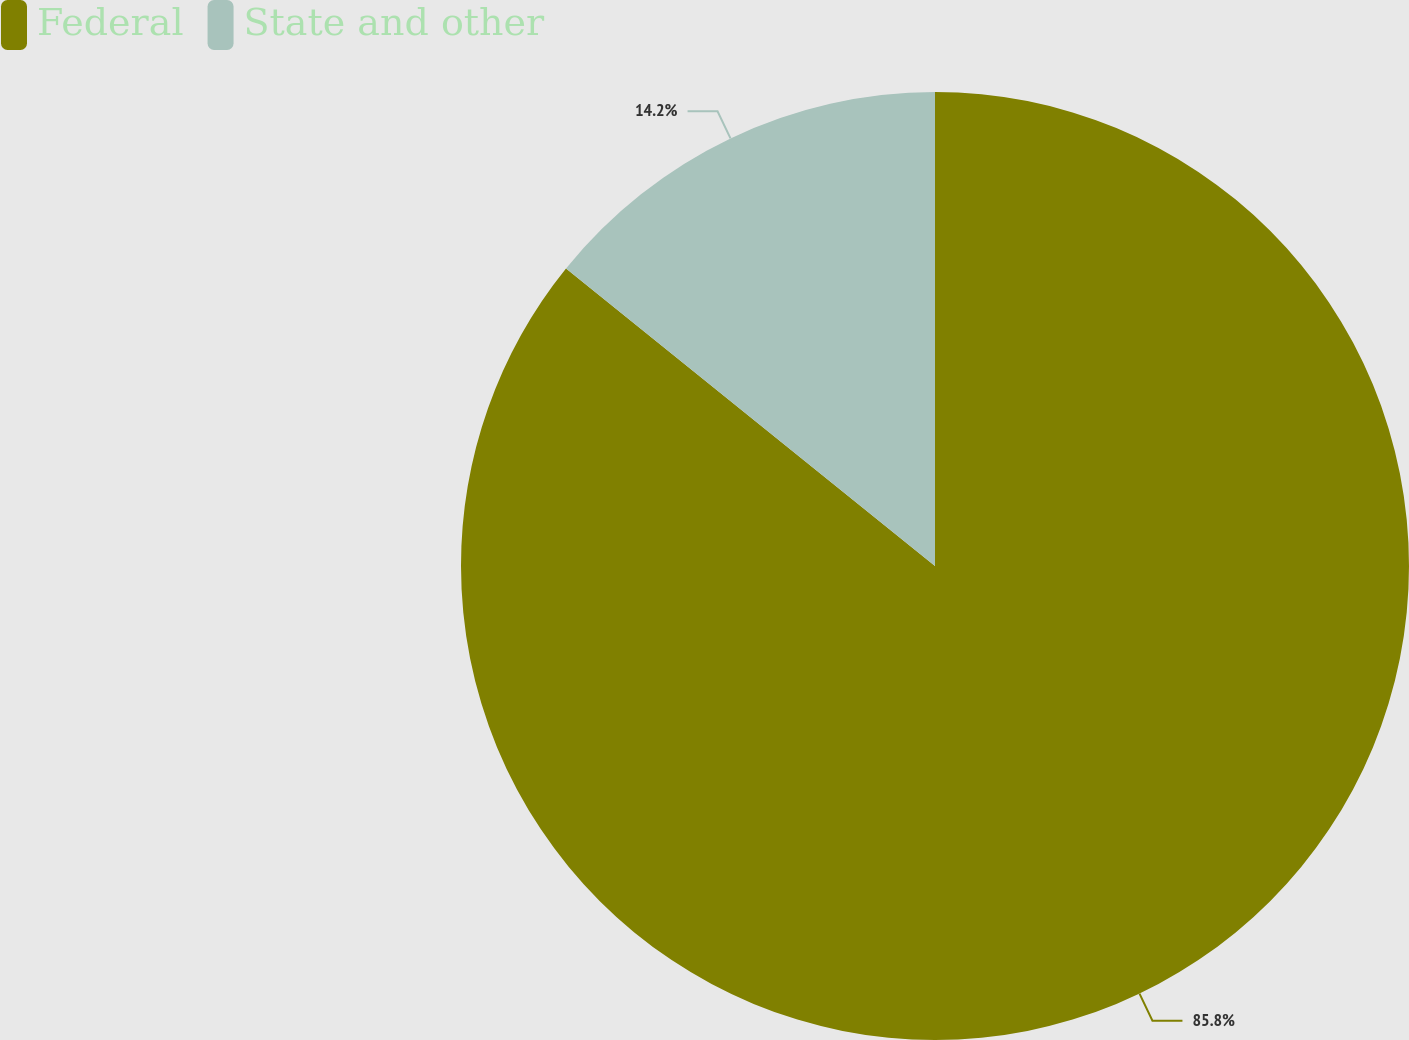Convert chart to OTSL. <chart><loc_0><loc_0><loc_500><loc_500><pie_chart><fcel>Federal<fcel>State and other<nl><fcel>85.8%<fcel>14.2%<nl></chart> 